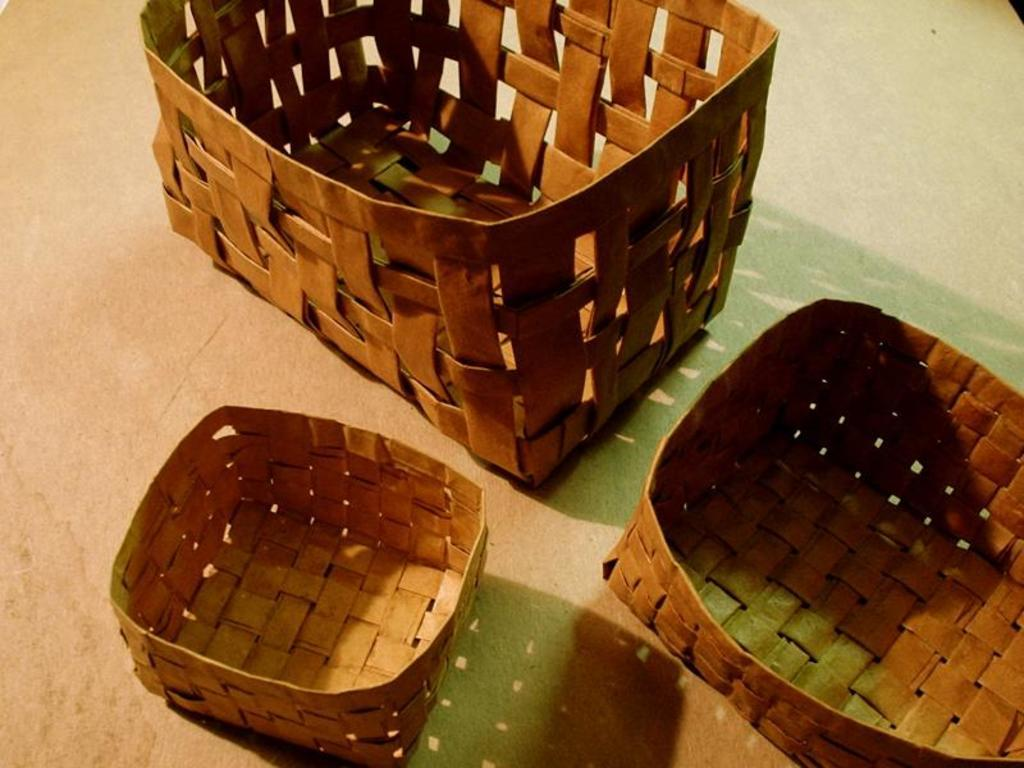What objects are present in the image? There are brackets in the image. Where are the brackets located in the image? The brackets are placed on the floor. What type of peace symbol can be seen on the side of the brackets in the image? There is no peace symbol present on the brackets or anywhere else in the image. 